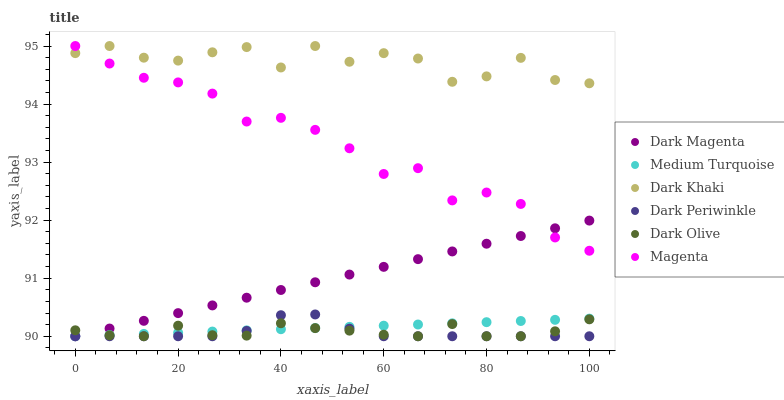Does Dark Periwinkle have the minimum area under the curve?
Answer yes or no. Yes. Does Dark Khaki have the maximum area under the curve?
Answer yes or no. Yes. Does Dark Olive have the minimum area under the curve?
Answer yes or no. No. Does Dark Olive have the maximum area under the curve?
Answer yes or no. No. Is Dark Magenta the smoothest?
Answer yes or no. Yes. Is Dark Khaki the roughest?
Answer yes or no. Yes. Is Dark Olive the smoothest?
Answer yes or no. No. Is Dark Olive the roughest?
Answer yes or no. No. Does Dark Magenta have the lowest value?
Answer yes or no. Yes. Does Dark Khaki have the lowest value?
Answer yes or no. No. Does Magenta have the highest value?
Answer yes or no. Yes. Does Dark Olive have the highest value?
Answer yes or no. No. Is Medium Turquoise less than Magenta?
Answer yes or no. Yes. Is Dark Khaki greater than Dark Periwinkle?
Answer yes or no. Yes. Does Dark Periwinkle intersect Dark Olive?
Answer yes or no. Yes. Is Dark Periwinkle less than Dark Olive?
Answer yes or no. No. Is Dark Periwinkle greater than Dark Olive?
Answer yes or no. No. Does Medium Turquoise intersect Magenta?
Answer yes or no. No. 